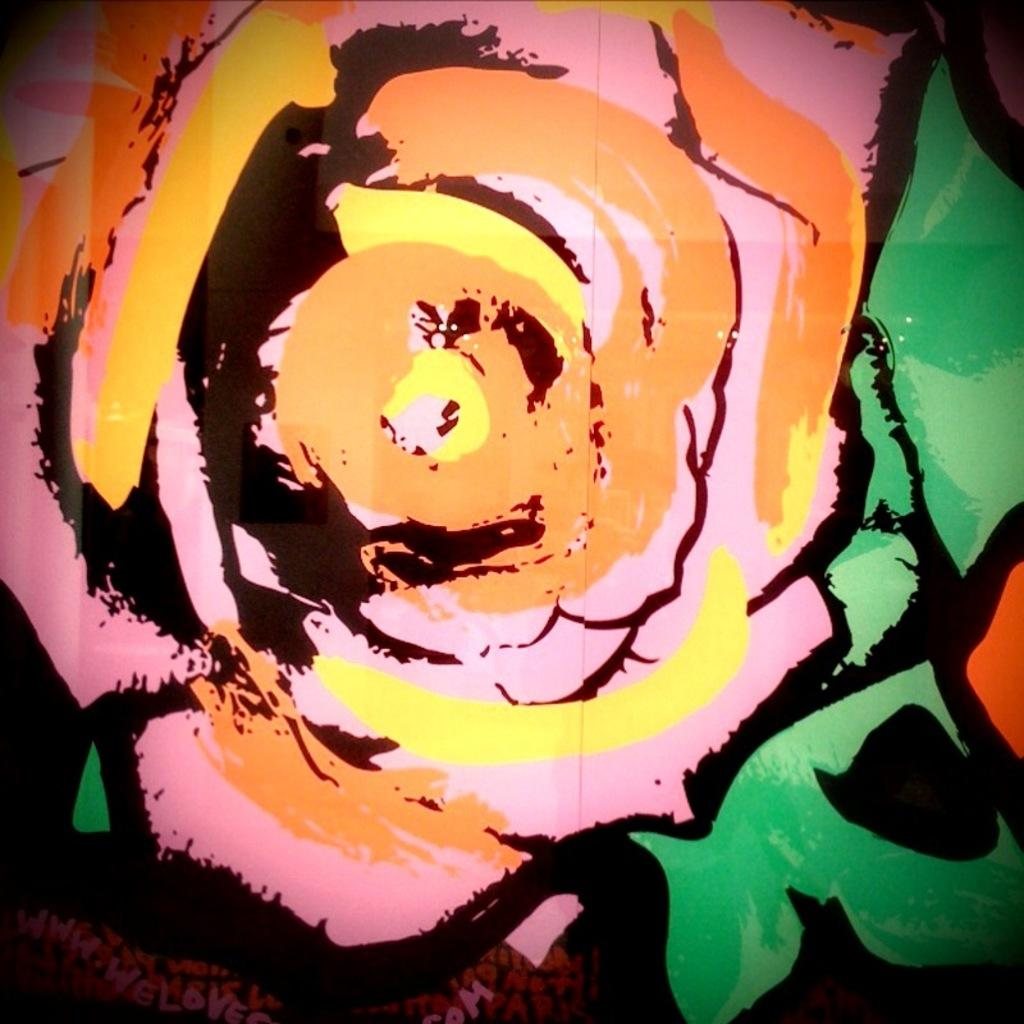What is the main subject of the image? The main subject of the image is a painting. Can you describe the location of the painting in the image? The painting is drawn over a place. How many trucks are visible in the painting? There is no information about trucks in the image or the painting; only the fact that the painting is drawn over a place is provided. 